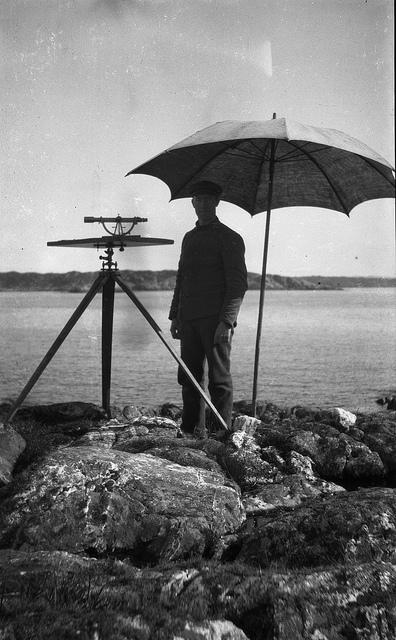How well is this man tolerating the flood?
Quick response, please. Well. What is he standing under?
Be succinct. Umbrella. Is this guy a scientist?
Keep it brief. Yes. Is the umbrella protecting him from?
Be succinct. Sun. 